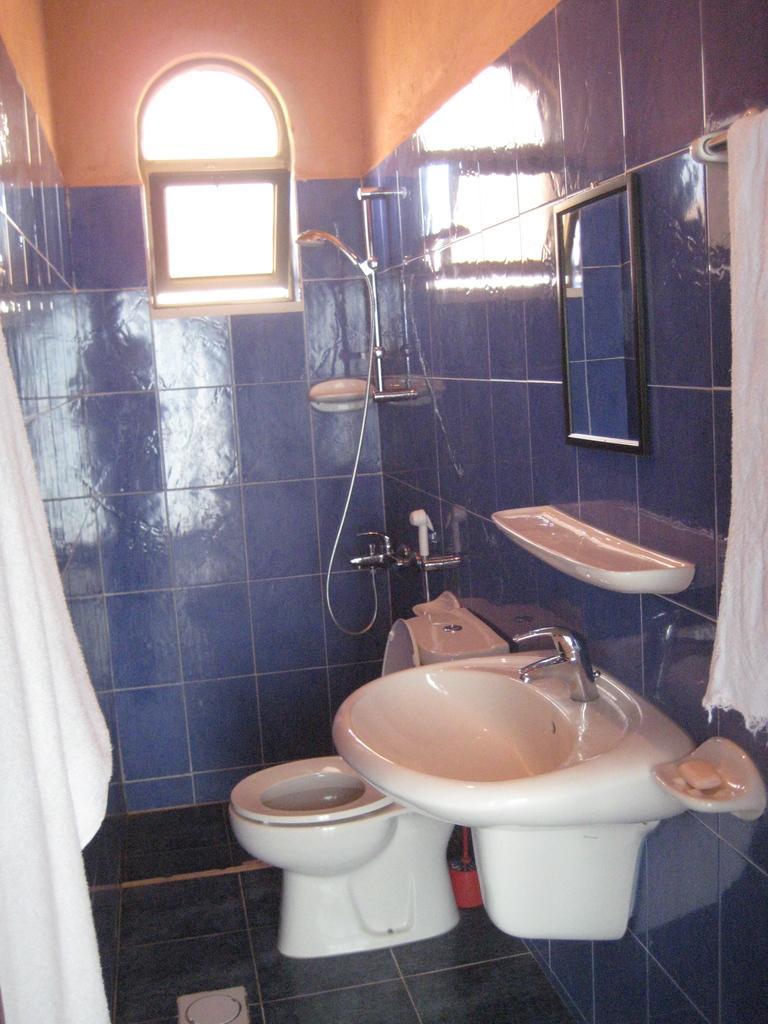Please provide a concise description of this image. In this picture I can observe white color toilet sink on the floor. On the right side there is a sink fixed to the wall. There is a tap. I can observe a mirror hanged to the wall on the right side. There is a towel on the towel bar. In the background there is a window. I can observe a wall which is in blue and orange color. 